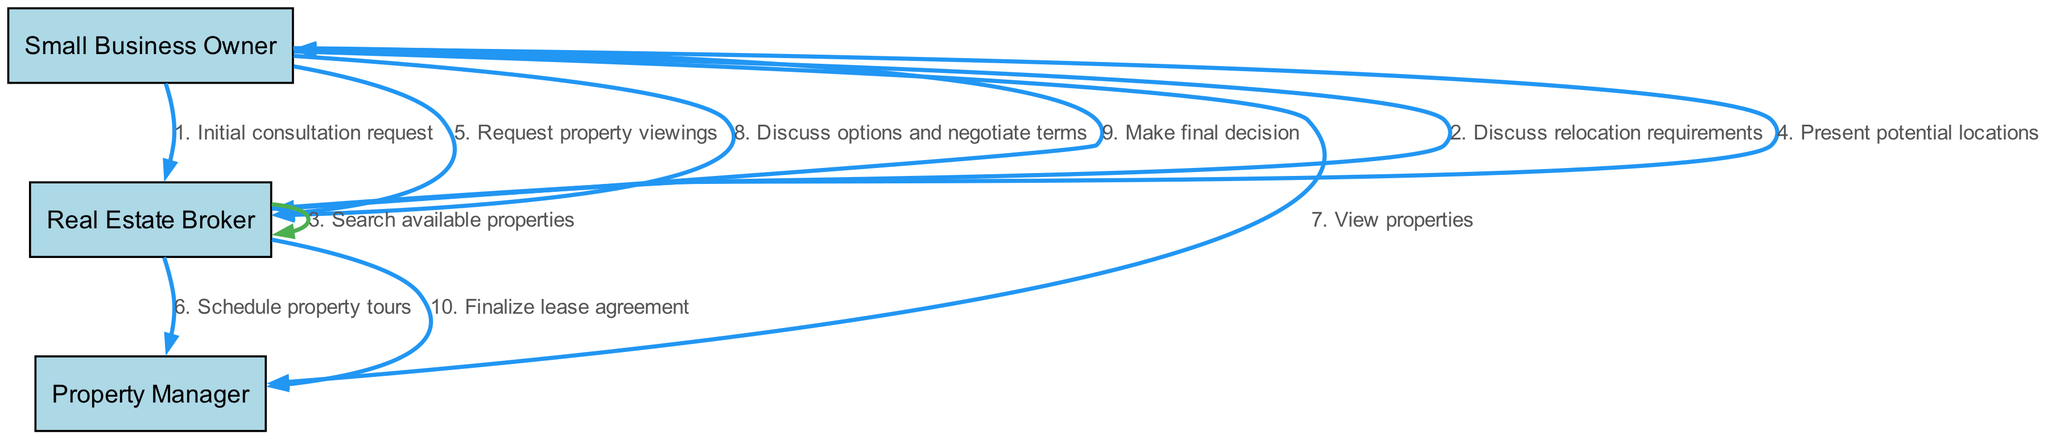What is the first message in the diagram? The first message is shown as the arrow from the Small Business Owner to the Real Estate Broker labeled "1. Initial consultation request". This indicates the starting point of the sequence.
Answer: Initial consultation request Who is responsible for scheduling property tours? In the diagram, the Real Estate Broker sends a message to the Property Manager to schedule property tours, indicating that this responsibility falls on the broker.
Answer: Real Estate Broker How many actors are in the diagram? The diagram features three actors: Small Business Owner, Real Estate Broker, and Property Manager. By counting the nodes at the top of the diagram, we can establish this total.
Answer: 3 Which two actors are involved in the discussion of options and negotiation of terms? The Small Business Owner sends a message to the Real Estate Broker to discuss options and negotiate terms. Therefore, these two actors are directly involved in this step.
Answer: Small Business Owner and Real Estate Broker After which message does the Small Business Owner make a final decision? The Small Business Owner makes a final decision after discussing options and negotiating terms with the Real Estate Broker, as indicated by the flow of messages leading to the final decision.
Answer: Discuss options and negotiate terms Which message is the last action taken by the Real Estate Broker? The last action taken by the Real Estate Broker is to finalize the lease agreement, as indicated by the final message directed to the Property Manager.
Answer: Finalize lease agreement 